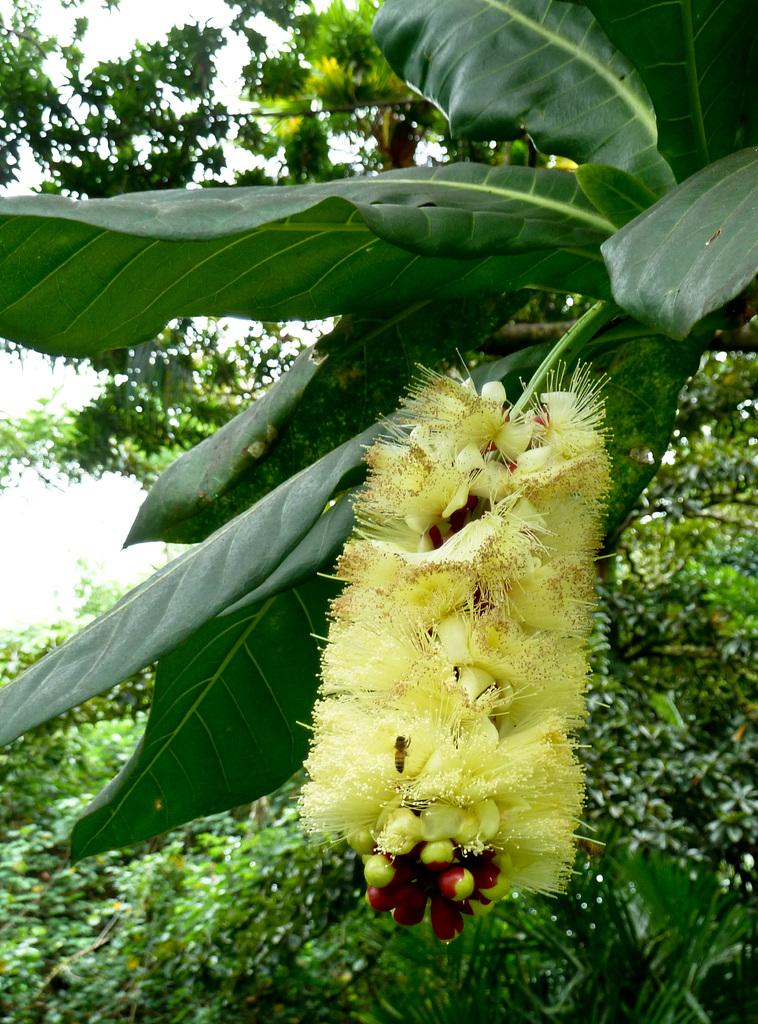What is on the tree in the image? There is a flower on the tree in the image. Is there anything else on the flower? Yes, there is an insect on the flower. What other trees can be seen in the image? There are trees in the image. What can be seen in the background of the image? The sky is visible in the background of the image. What type of beef can be seen grazing near the seashore in the image? There is no beef or seashore present in the image; it features a tree with a flower and an insect. Can you hear the voice of the insect in the image? Insects do not have voices, so it is not possible to hear the insect's voice in the image. 